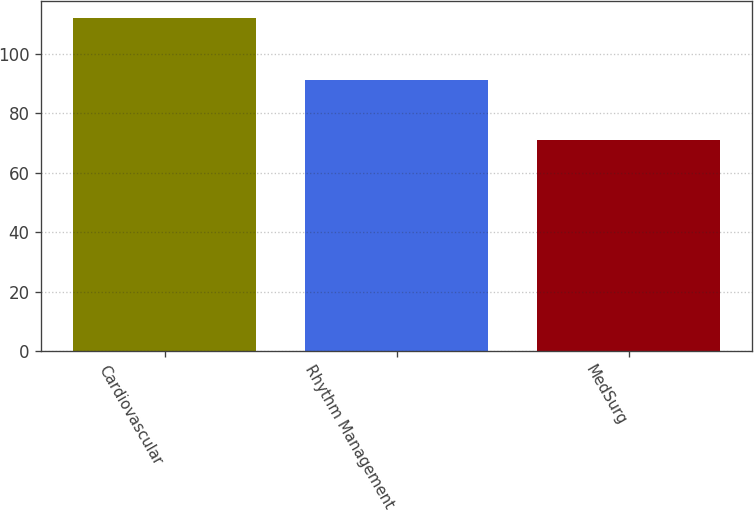Convert chart. <chart><loc_0><loc_0><loc_500><loc_500><bar_chart><fcel>Cardiovascular<fcel>Rhythm Management<fcel>MedSurg<nl><fcel>112<fcel>91<fcel>71<nl></chart> 